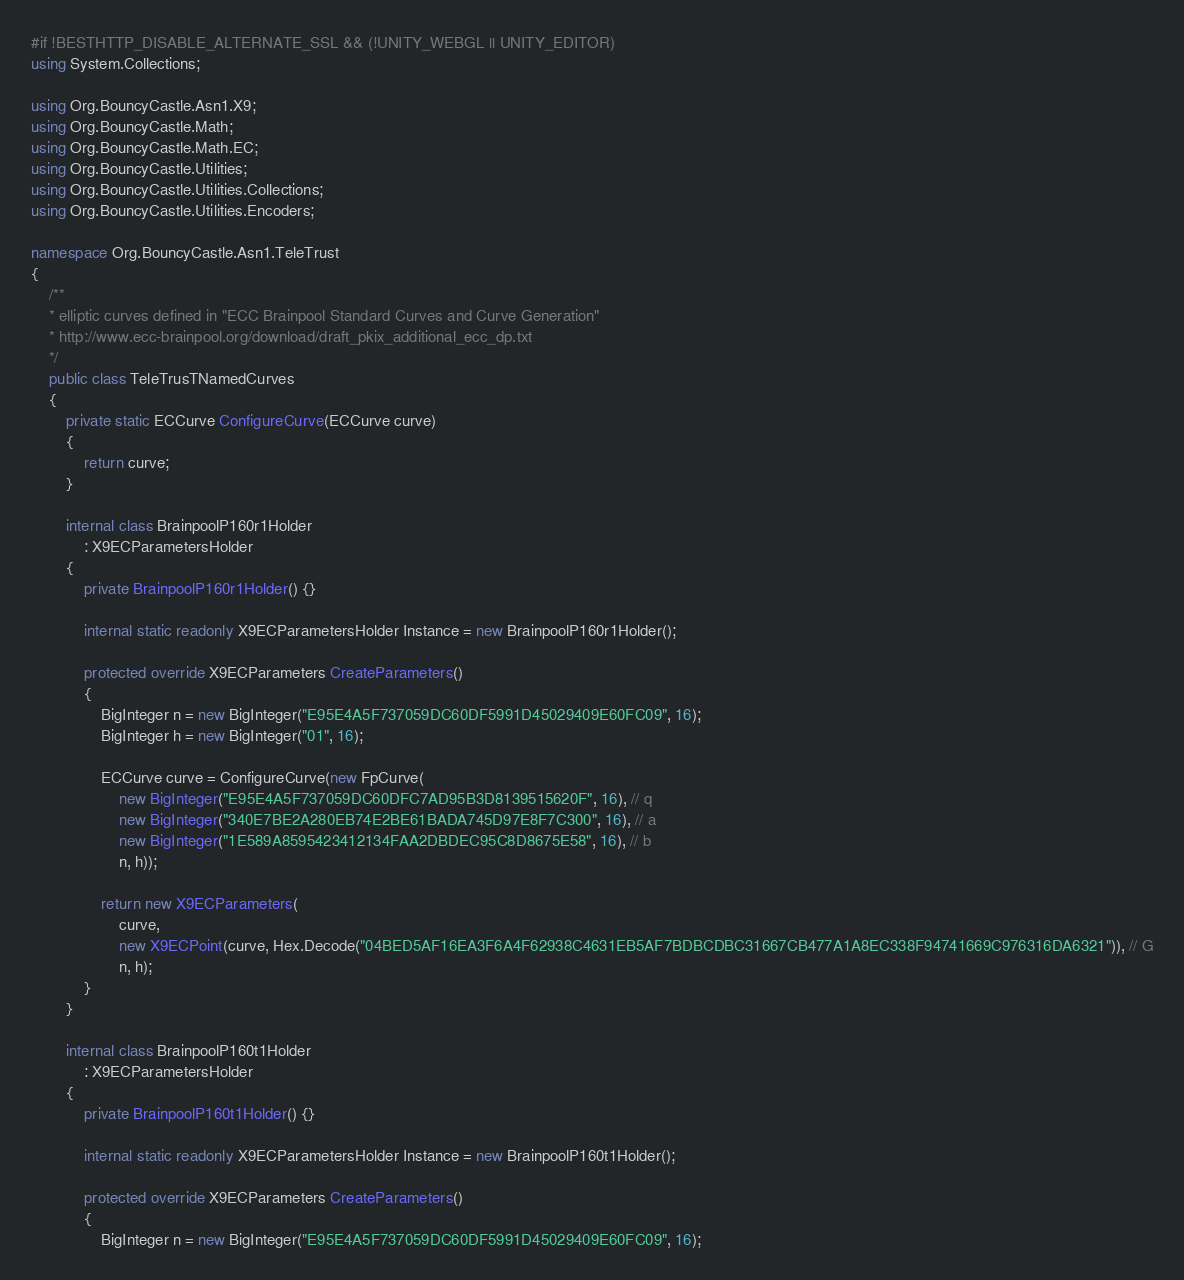<code> <loc_0><loc_0><loc_500><loc_500><_C#_>#if !BESTHTTP_DISABLE_ALTERNATE_SSL && (!UNITY_WEBGL || UNITY_EDITOR)
using System.Collections;

using Org.BouncyCastle.Asn1.X9;
using Org.BouncyCastle.Math;
using Org.BouncyCastle.Math.EC;
using Org.BouncyCastle.Utilities;
using Org.BouncyCastle.Utilities.Collections;
using Org.BouncyCastle.Utilities.Encoders;

namespace Org.BouncyCastle.Asn1.TeleTrust
{
    /**
    * elliptic curves defined in "ECC Brainpool Standard Curves and Curve Generation"
    * http://www.ecc-brainpool.org/download/draft_pkix_additional_ecc_dp.txt
    */
    public class TeleTrusTNamedCurves
    {
        private static ECCurve ConfigureCurve(ECCurve curve)
        {
            return curve;
        }

        internal class BrainpoolP160r1Holder
            : X9ECParametersHolder
        {
            private BrainpoolP160r1Holder() {}

            internal static readonly X9ECParametersHolder Instance = new BrainpoolP160r1Holder();

            protected override X9ECParameters CreateParameters()
            {
                BigInteger n = new BigInteger("E95E4A5F737059DC60DF5991D45029409E60FC09", 16);
                BigInteger h = new BigInteger("01", 16);

                ECCurve curve = ConfigureCurve(new FpCurve(
                    new BigInteger("E95E4A5F737059DC60DFC7AD95B3D8139515620F", 16), // q
                    new BigInteger("340E7BE2A280EB74E2BE61BADA745D97E8F7C300", 16), // a
                    new BigInteger("1E589A8595423412134FAA2DBDEC95C8D8675E58", 16), // b
                    n, h));

                return new X9ECParameters(
                    curve,
                    new X9ECPoint(curve, Hex.Decode("04BED5AF16EA3F6A4F62938C4631EB5AF7BDBCDBC31667CB477A1A8EC338F94741669C976316DA6321")), // G
                    n, h);
            }
        }

        internal class BrainpoolP160t1Holder
            : X9ECParametersHolder
        {
            private BrainpoolP160t1Holder() {}

            internal static readonly X9ECParametersHolder Instance = new BrainpoolP160t1Holder();

            protected override X9ECParameters CreateParameters()
            {
                BigInteger n = new BigInteger("E95E4A5F737059DC60DF5991D45029409E60FC09", 16);</code> 